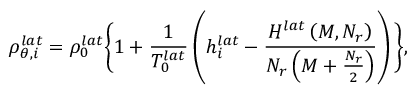<formula> <loc_0><loc_0><loc_500><loc_500>\rho _ { \theta , i } ^ { l a t } = \rho _ { 0 } ^ { l a t } \left \{ 1 + \frac { 1 } { T _ { 0 } ^ { l a t } } \left ( h _ { i } ^ { l a t } - \frac { H ^ { l a t } \left ( M , N _ { r } \right ) } { N _ { r } \left ( M + \frac { N _ { r } } { 2 } \right ) } \right ) \right \} ,</formula> 